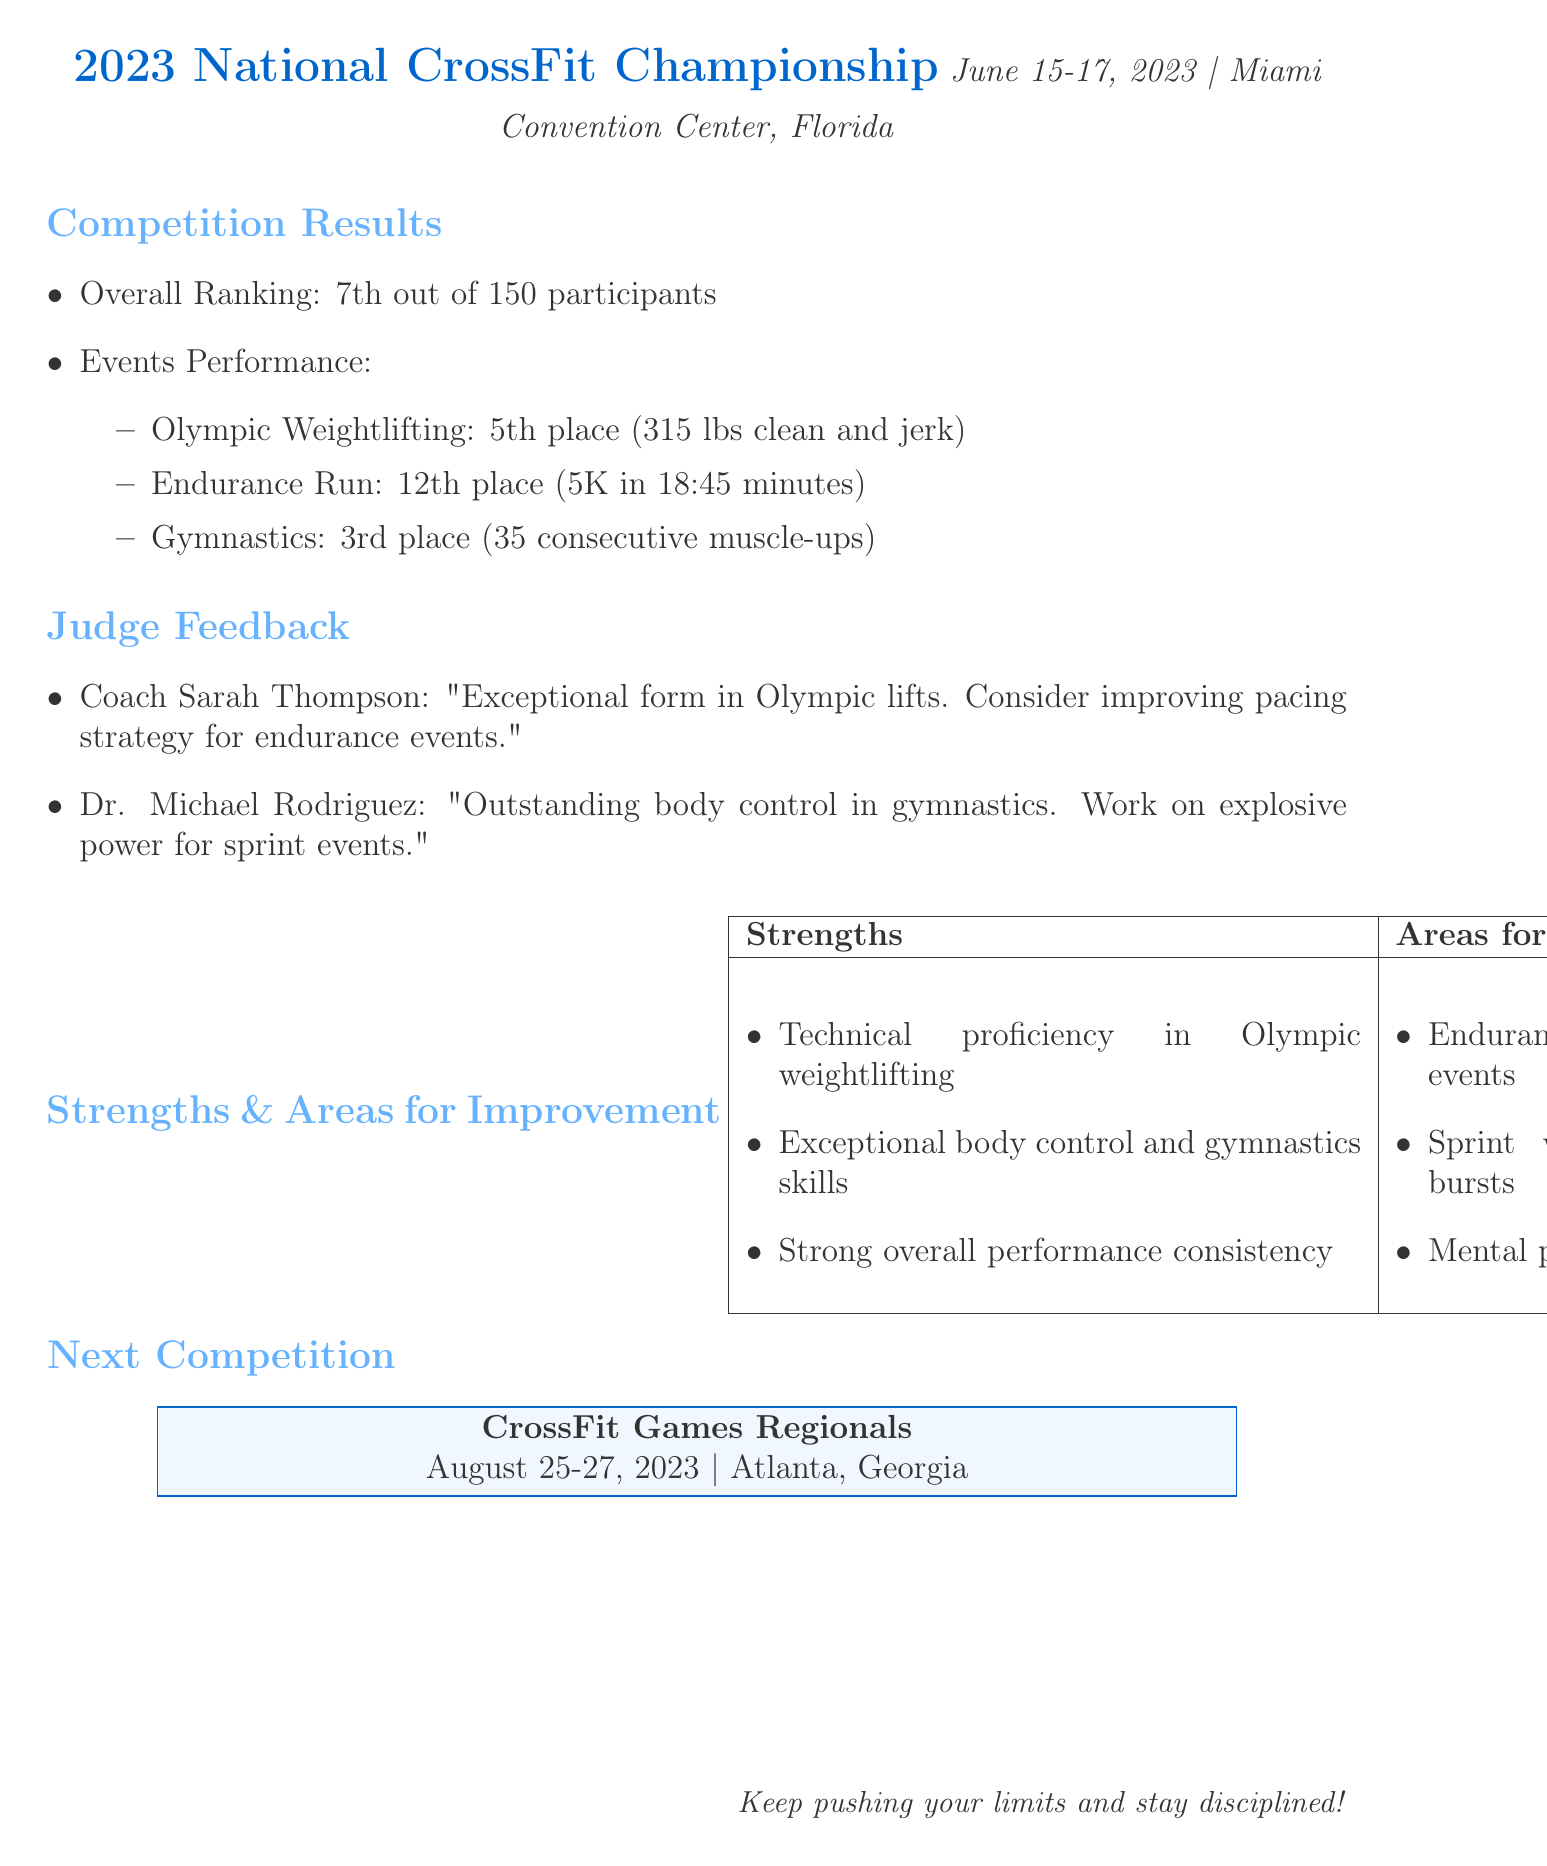What is the overall ranking in the competition? The overall ranking is listed in the document under "Competition Results," which is 7th out of 150 participants.
Answer: 7th out of 150 participants What was the score for Olympic Weightlifting? The score for Olympic Weightlifting is found in "Events Performance," which specifies 315 lbs clean and jerk.
Answer: 315 lbs clean and jerk Who provided feedback on the Endurance Run event? The judge's feedback is detailed in the document, and comments about the Endurance Run are from Coach Sarah Thompson.
Answer: Coach Sarah Thompson What is one of the areas for improvement mentioned? Specific areas for improvement are listed in the document, one of which is "Endurance training for longer distance events."
Answer: Endurance training for longer distance events What is the date of the next competition? The date of the next competition can be found in the "Next Competition" section, which is August 25-27, 2023.
Answer: August 25-27, 2023 